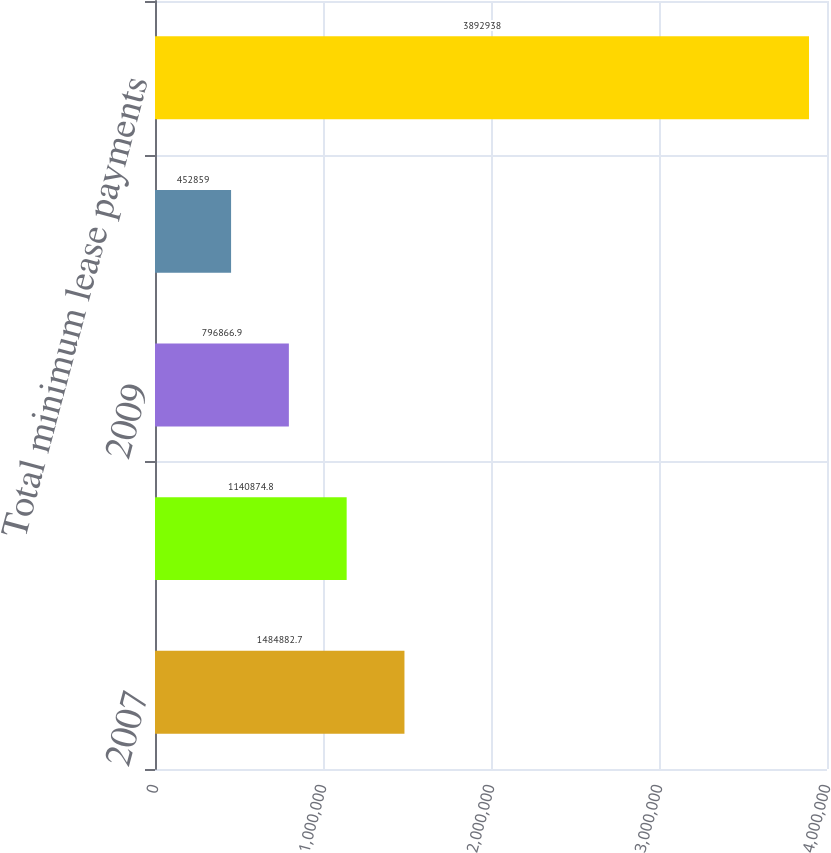Convert chart to OTSL. <chart><loc_0><loc_0><loc_500><loc_500><bar_chart><fcel>2007<fcel>2008<fcel>2009<fcel>2010<fcel>Total minimum lease payments<nl><fcel>1.48488e+06<fcel>1.14087e+06<fcel>796867<fcel>452859<fcel>3.89294e+06<nl></chart> 